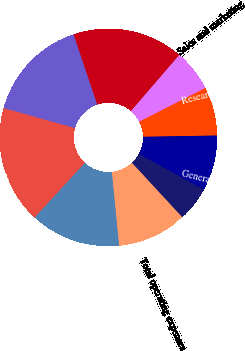Convert chart. <chart><loc_0><loc_0><loc_500><loc_500><pie_chart><fcel>NET SALES<fcel>COST OF SALES<fcel>GROSS PROFIT<fcel>Sales and marketing<fcel>Research and development<fcel>General and administrative<fcel>(Gain) loss on foreign<fcel>Total operating expenses<fcel>OPERATING INCOME<fcel>Interest (expense) income net<nl><fcel>17.53%<fcel>15.46%<fcel>16.49%<fcel>6.19%<fcel>7.22%<fcel>8.25%<fcel>5.15%<fcel>10.31%<fcel>13.4%<fcel>0.0%<nl></chart> 